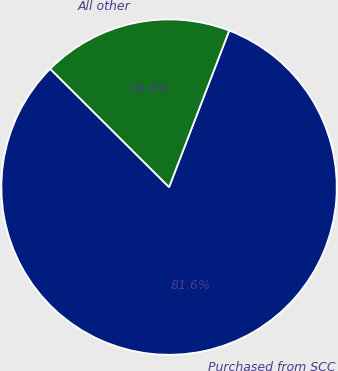Convert chart. <chart><loc_0><loc_0><loc_500><loc_500><pie_chart><fcel>Purchased from SCC<fcel>All other<nl><fcel>81.62%<fcel>18.38%<nl></chart> 